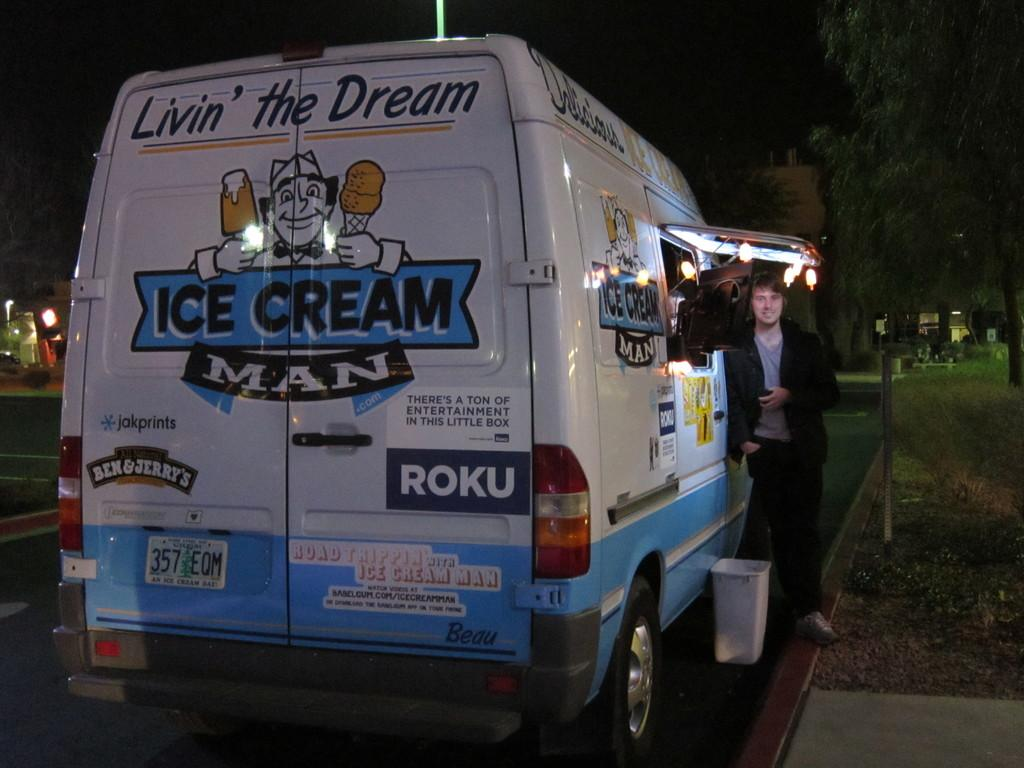<image>
Present a compact description of the photo's key features. A food truck with the words ice cream man on back and livin the dream on top. 